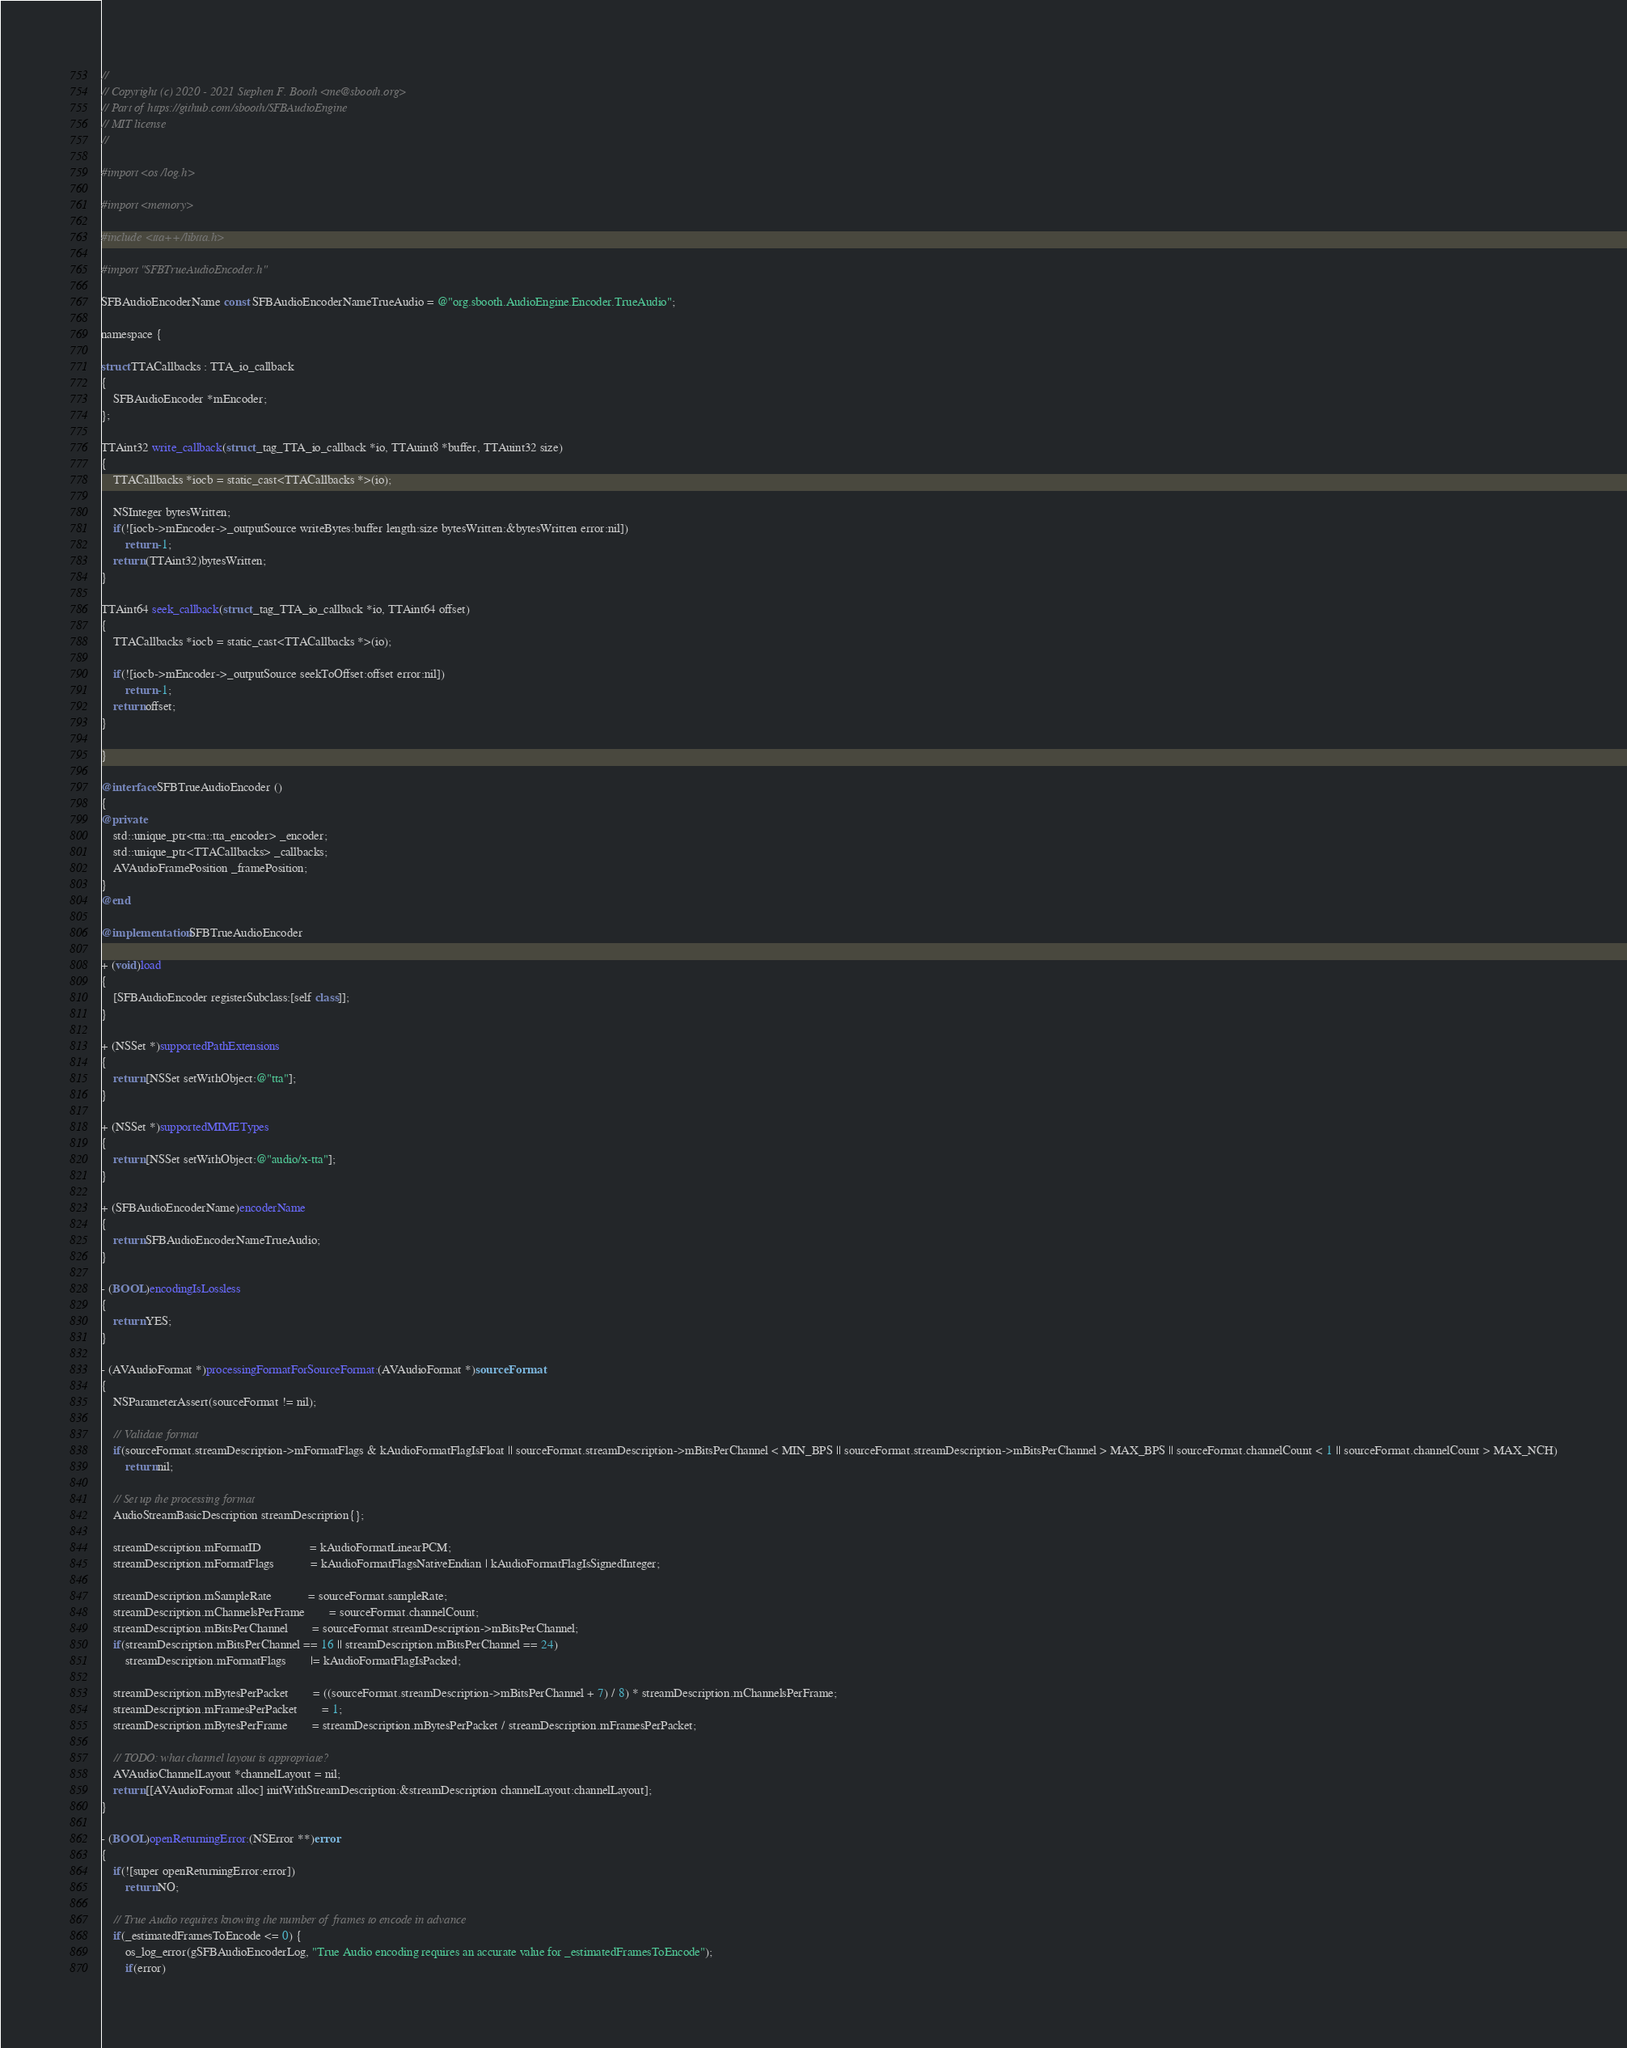Convert code to text. <code><loc_0><loc_0><loc_500><loc_500><_ObjectiveC_>//
// Copyright (c) 2020 - 2021 Stephen F. Booth <me@sbooth.org>
// Part of https://github.com/sbooth/SFBAudioEngine
// MIT license
//

#import <os/log.h>

#import <memory>

#include <tta++/libtta.h>

#import "SFBTrueAudioEncoder.h"

SFBAudioEncoderName const SFBAudioEncoderNameTrueAudio = @"org.sbooth.AudioEngine.Encoder.TrueAudio";

namespace {

struct TTACallbacks : TTA_io_callback
{
	SFBAudioEncoder *mEncoder;
};

TTAint32 write_callback(struct _tag_TTA_io_callback *io, TTAuint8 *buffer, TTAuint32 size)
{
	TTACallbacks *iocb = static_cast<TTACallbacks *>(io);

	NSInteger bytesWritten;
	if(![iocb->mEncoder->_outputSource writeBytes:buffer length:size bytesWritten:&bytesWritten error:nil])
		return -1;
	return (TTAint32)bytesWritten;
}

TTAint64 seek_callback(struct _tag_TTA_io_callback *io, TTAint64 offset)
{
	TTACallbacks *iocb = static_cast<TTACallbacks *>(io);

	if(![iocb->mEncoder->_outputSource seekToOffset:offset error:nil])
		return -1;
	return offset;
}

}

@interface SFBTrueAudioEncoder ()
{
@private
	std::unique_ptr<tta::tta_encoder> _encoder;
	std::unique_ptr<TTACallbacks> _callbacks;
	AVAudioFramePosition _framePosition;
}
@end

@implementation SFBTrueAudioEncoder

+ (void)load
{
	[SFBAudioEncoder registerSubclass:[self class]];
}

+ (NSSet *)supportedPathExtensions
{
	return [NSSet setWithObject:@"tta"];
}

+ (NSSet *)supportedMIMETypes
{
	return [NSSet setWithObject:@"audio/x-tta"];
}

+ (SFBAudioEncoderName)encoderName
{
	return SFBAudioEncoderNameTrueAudio;
}

- (BOOL)encodingIsLossless
{
	return YES;
}

- (AVAudioFormat *)processingFormatForSourceFormat:(AVAudioFormat *)sourceFormat
{
	NSParameterAssert(sourceFormat != nil);

	// Validate format
	if(sourceFormat.streamDescription->mFormatFlags & kAudioFormatFlagIsFloat || sourceFormat.streamDescription->mBitsPerChannel < MIN_BPS || sourceFormat.streamDescription->mBitsPerChannel > MAX_BPS || sourceFormat.channelCount < 1 || sourceFormat.channelCount > MAX_NCH)
		return nil;

	// Set up the processing format
	AudioStreamBasicDescription streamDescription{};

	streamDescription.mFormatID				= kAudioFormatLinearPCM;
	streamDescription.mFormatFlags			= kAudioFormatFlagsNativeEndian | kAudioFormatFlagIsSignedInteger;

	streamDescription.mSampleRate			= sourceFormat.sampleRate;
	streamDescription.mChannelsPerFrame		= sourceFormat.channelCount;
	streamDescription.mBitsPerChannel		= sourceFormat.streamDescription->mBitsPerChannel;
	if(streamDescription.mBitsPerChannel == 16 || streamDescription.mBitsPerChannel == 24)
		streamDescription.mFormatFlags		|= kAudioFormatFlagIsPacked;

	streamDescription.mBytesPerPacket		= ((sourceFormat.streamDescription->mBitsPerChannel + 7) / 8) * streamDescription.mChannelsPerFrame;
	streamDescription.mFramesPerPacket		= 1;
	streamDescription.mBytesPerFrame		= streamDescription.mBytesPerPacket / streamDescription.mFramesPerPacket;

	// TODO: what channel layout is appropriate?
	AVAudioChannelLayout *channelLayout = nil;
	return [[AVAudioFormat alloc] initWithStreamDescription:&streamDescription channelLayout:channelLayout];
}

- (BOOL)openReturningError:(NSError **)error
{
	if(![super openReturningError:error])
		return NO;

	// True Audio requires knowing the number of frames to encode in advance
	if(_estimatedFramesToEncode <= 0) {
		os_log_error(gSFBAudioEncoderLog, "True Audio encoding requires an accurate value for _estimatedFramesToEncode");
		if(error)</code> 